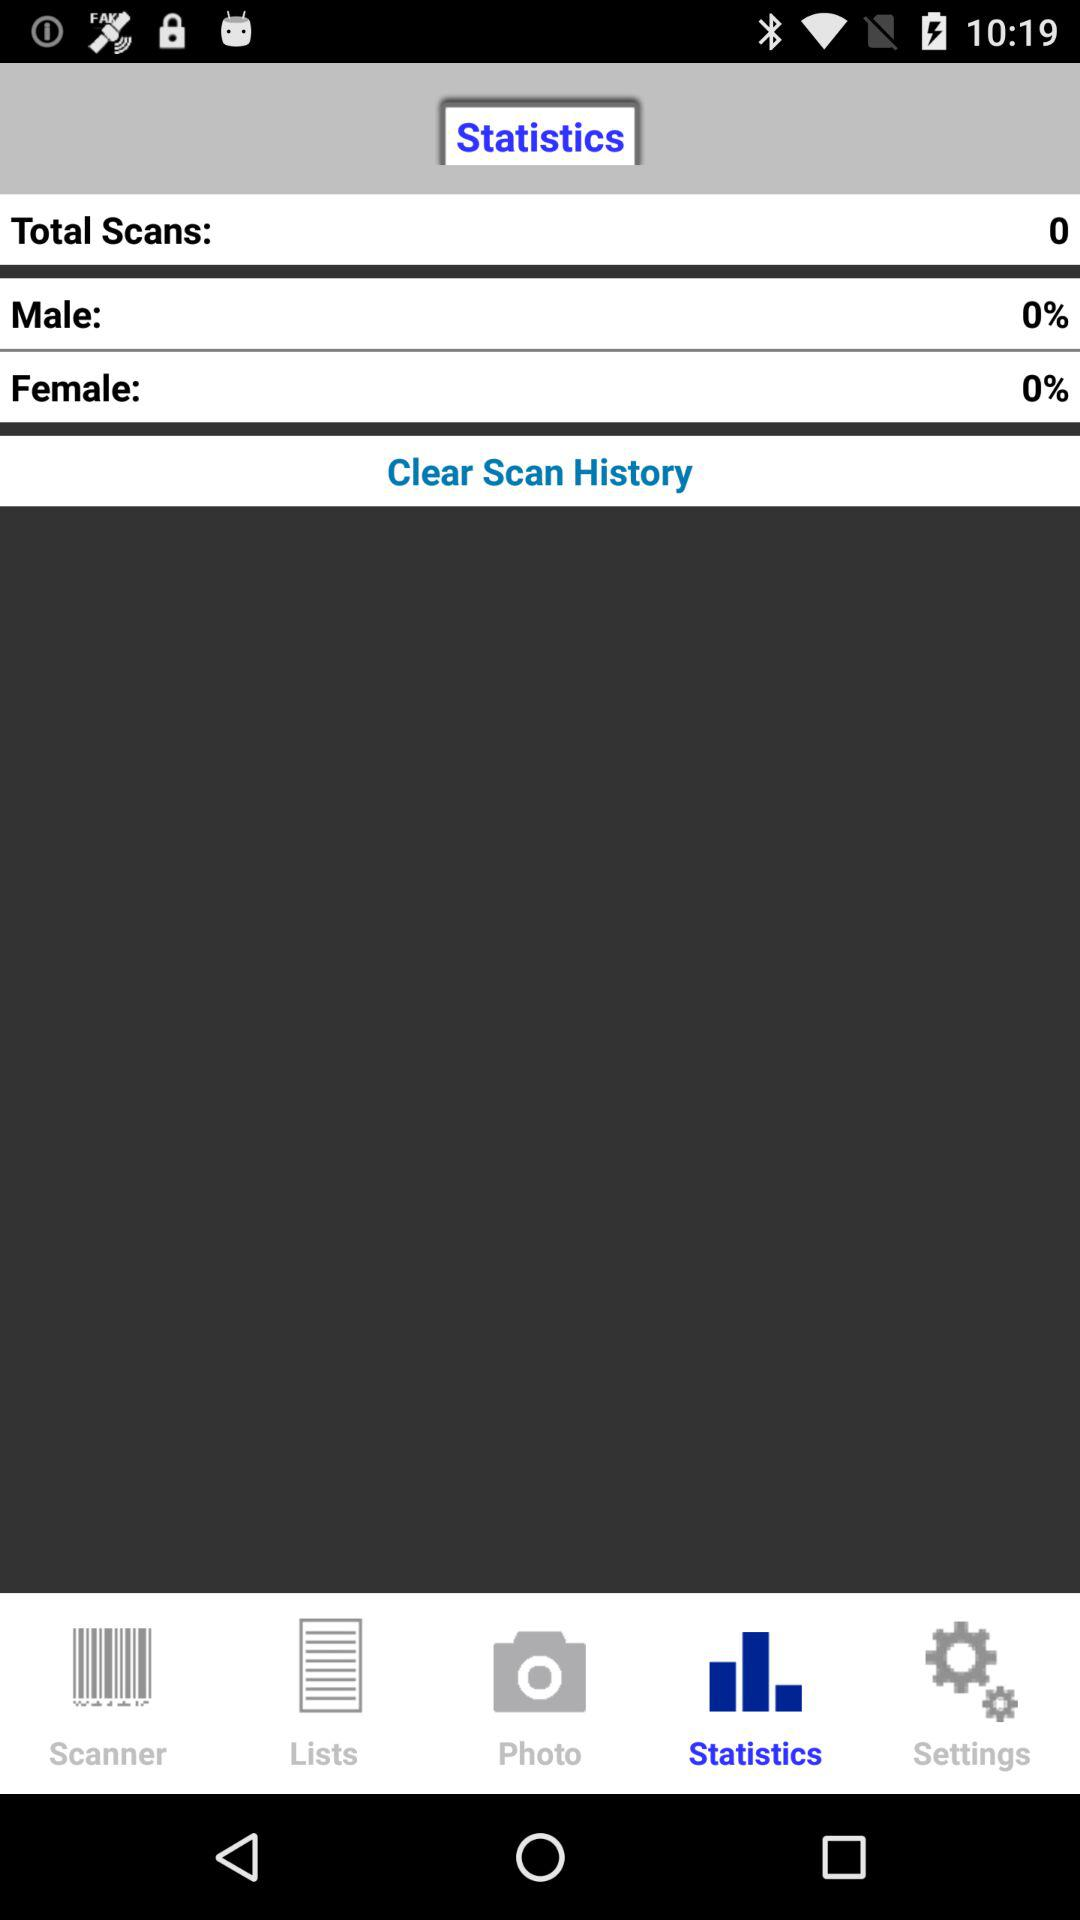What is the selected tab? The selected tab is "Statistics". 